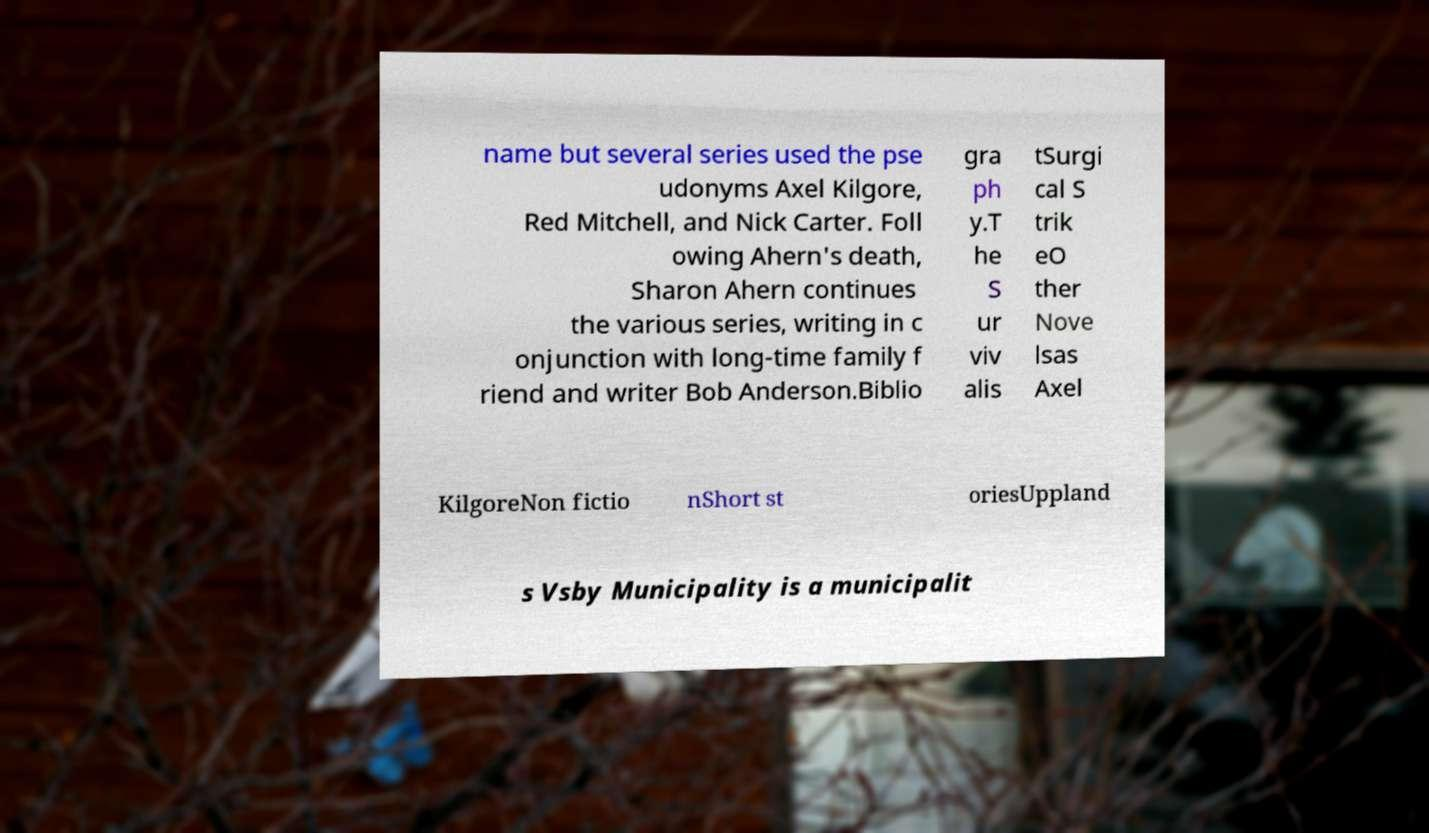Could you assist in decoding the text presented in this image and type it out clearly? name but several series used the pse udonyms Axel Kilgore, Red Mitchell, and Nick Carter. Foll owing Ahern's death, Sharon Ahern continues the various series, writing in c onjunction with long-time family f riend and writer Bob Anderson.Biblio gra ph y.T he S ur viv alis tSurgi cal S trik eO ther Nove lsas Axel KilgoreNon fictio nShort st oriesUppland s Vsby Municipality is a municipalit 